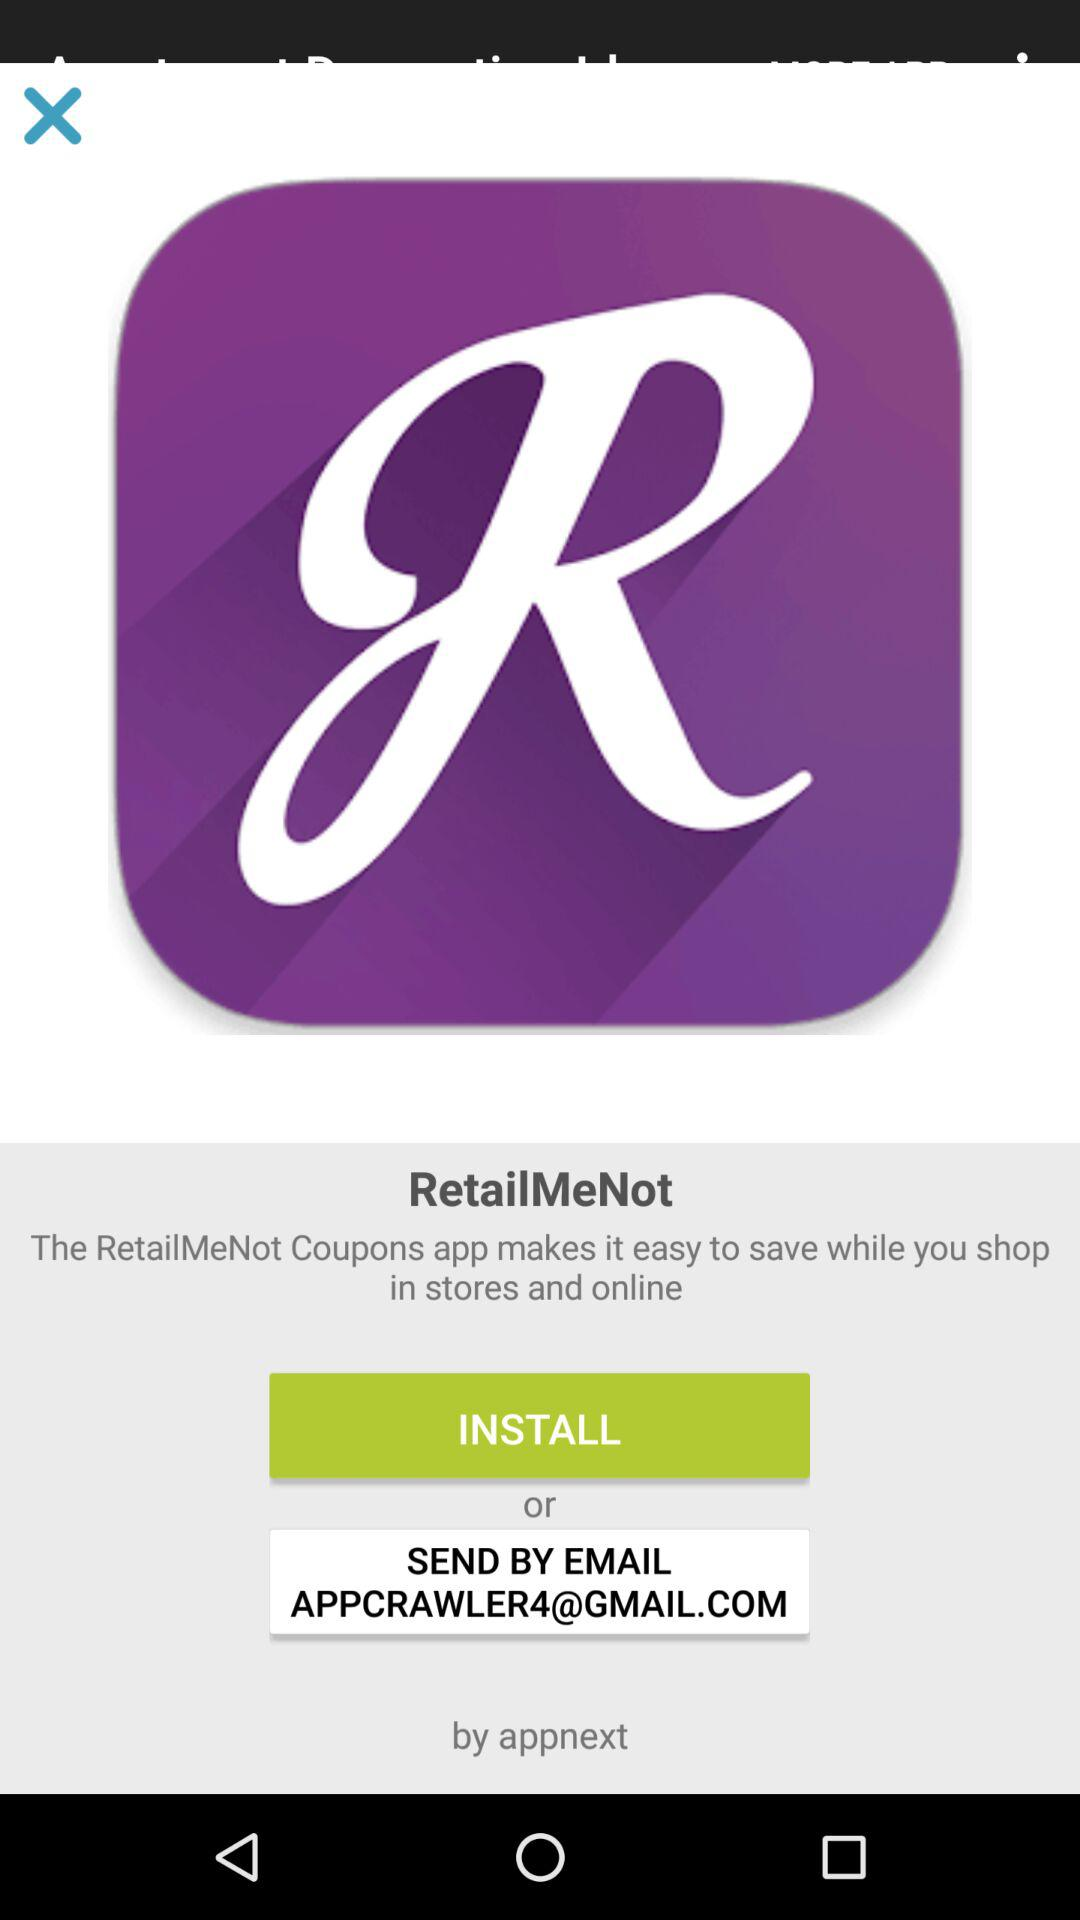What app makes it easy to save while you shop in stores and online? The app that makes it easy to save while you shop in stores and online is "RetailMeNot Coupons". 